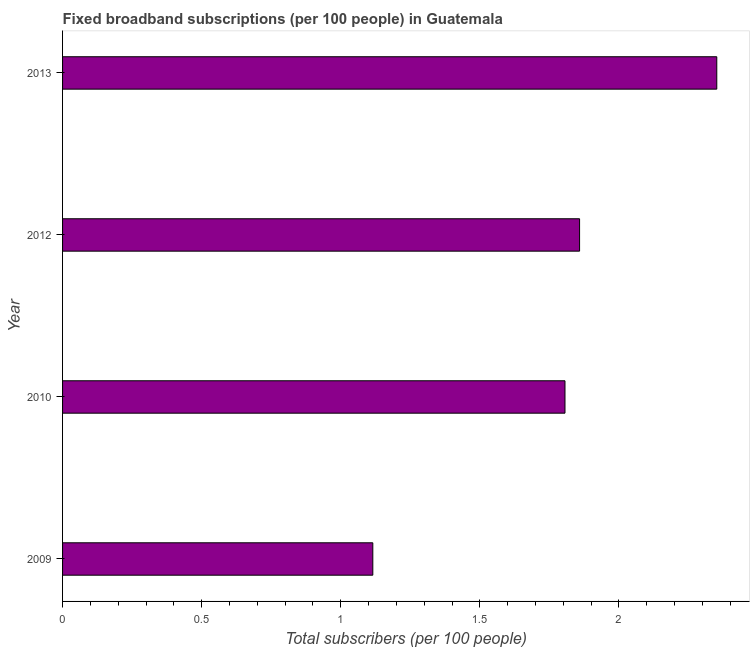Does the graph contain any zero values?
Offer a terse response. No. What is the title of the graph?
Your answer should be compact. Fixed broadband subscriptions (per 100 people) in Guatemala. What is the label or title of the X-axis?
Ensure brevity in your answer.  Total subscribers (per 100 people). What is the total number of fixed broadband subscriptions in 2012?
Ensure brevity in your answer.  1.86. Across all years, what is the maximum total number of fixed broadband subscriptions?
Provide a succinct answer. 2.35. Across all years, what is the minimum total number of fixed broadband subscriptions?
Offer a terse response. 1.12. In which year was the total number of fixed broadband subscriptions maximum?
Your answer should be compact. 2013. In which year was the total number of fixed broadband subscriptions minimum?
Provide a short and direct response. 2009. What is the sum of the total number of fixed broadband subscriptions?
Your answer should be compact. 7.13. What is the difference between the total number of fixed broadband subscriptions in 2010 and 2012?
Make the answer very short. -0.05. What is the average total number of fixed broadband subscriptions per year?
Provide a succinct answer. 1.78. What is the median total number of fixed broadband subscriptions?
Keep it short and to the point. 1.83. In how many years, is the total number of fixed broadband subscriptions greater than 0.5 ?
Offer a terse response. 4. What is the ratio of the total number of fixed broadband subscriptions in 2009 to that in 2012?
Your answer should be compact. 0.6. Is the total number of fixed broadband subscriptions in 2009 less than that in 2010?
Give a very brief answer. Yes. What is the difference between the highest and the second highest total number of fixed broadband subscriptions?
Ensure brevity in your answer.  0.49. Is the sum of the total number of fixed broadband subscriptions in 2009 and 2013 greater than the maximum total number of fixed broadband subscriptions across all years?
Your answer should be compact. Yes. What is the difference between the highest and the lowest total number of fixed broadband subscriptions?
Your answer should be very brief. 1.24. How many bars are there?
Your answer should be compact. 4. How many years are there in the graph?
Your answer should be very brief. 4. What is the Total subscribers (per 100 people) of 2009?
Provide a succinct answer. 1.12. What is the Total subscribers (per 100 people) in 2010?
Your answer should be very brief. 1.81. What is the Total subscribers (per 100 people) of 2012?
Your answer should be very brief. 1.86. What is the Total subscribers (per 100 people) in 2013?
Offer a terse response. 2.35. What is the difference between the Total subscribers (per 100 people) in 2009 and 2010?
Your answer should be compact. -0.69. What is the difference between the Total subscribers (per 100 people) in 2009 and 2012?
Offer a terse response. -0.74. What is the difference between the Total subscribers (per 100 people) in 2009 and 2013?
Offer a very short reply. -1.24. What is the difference between the Total subscribers (per 100 people) in 2010 and 2012?
Provide a short and direct response. -0.05. What is the difference between the Total subscribers (per 100 people) in 2010 and 2013?
Make the answer very short. -0.55. What is the difference between the Total subscribers (per 100 people) in 2012 and 2013?
Your answer should be very brief. -0.49. What is the ratio of the Total subscribers (per 100 people) in 2009 to that in 2010?
Ensure brevity in your answer.  0.62. What is the ratio of the Total subscribers (per 100 people) in 2009 to that in 2013?
Provide a short and direct response. 0.47. What is the ratio of the Total subscribers (per 100 people) in 2010 to that in 2012?
Provide a short and direct response. 0.97. What is the ratio of the Total subscribers (per 100 people) in 2010 to that in 2013?
Make the answer very short. 0.77. What is the ratio of the Total subscribers (per 100 people) in 2012 to that in 2013?
Make the answer very short. 0.79. 